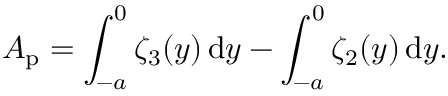Convert formula to latex. <formula><loc_0><loc_0><loc_500><loc_500>A _ { p } = \int _ { - a } ^ { 0 } \zeta _ { 3 } ( y ) \, d y - \int _ { - a } ^ { 0 } \zeta _ { 2 } ( y ) \, d y .</formula> 